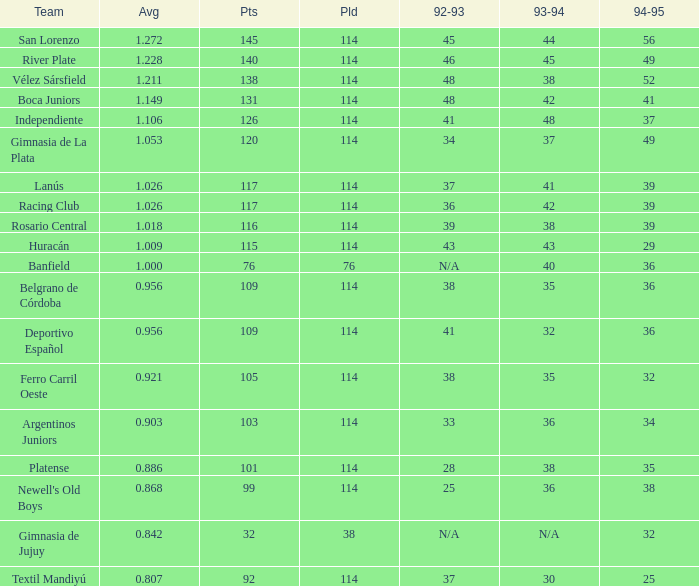Name the most played 114.0. 